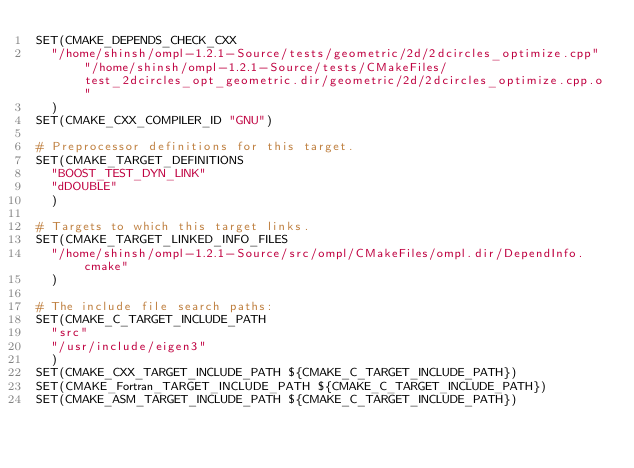<code> <loc_0><loc_0><loc_500><loc_500><_CMake_>SET(CMAKE_DEPENDS_CHECK_CXX
  "/home/shinsh/ompl-1.2.1-Source/tests/geometric/2d/2dcircles_optimize.cpp" "/home/shinsh/ompl-1.2.1-Source/tests/CMakeFiles/test_2dcircles_opt_geometric.dir/geometric/2d/2dcircles_optimize.cpp.o"
  )
SET(CMAKE_CXX_COMPILER_ID "GNU")

# Preprocessor definitions for this target.
SET(CMAKE_TARGET_DEFINITIONS
  "BOOST_TEST_DYN_LINK"
  "dDOUBLE"
  )

# Targets to which this target links.
SET(CMAKE_TARGET_LINKED_INFO_FILES
  "/home/shinsh/ompl-1.2.1-Source/src/ompl/CMakeFiles/ompl.dir/DependInfo.cmake"
  )

# The include file search paths:
SET(CMAKE_C_TARGET_INCLUDE_PATH
  "src"
  "/usr/include/eigen3"
  )
SET(CMAKE_CXX_TARGET_INCLUDE_PATH ${CMAKE_C_TARGET_INCLUDE_PATH})
SET(CMAKE_Fortran_TARGET_INCLUDE_PATH ${CMAKE_C_TARGET_INCLUDE_PATH})
SET(CMAKE_ASM_TARGET_INCLUDE_PATH ${CMAKE_C_TARGET_INCLUDE_PATH})
</code> 